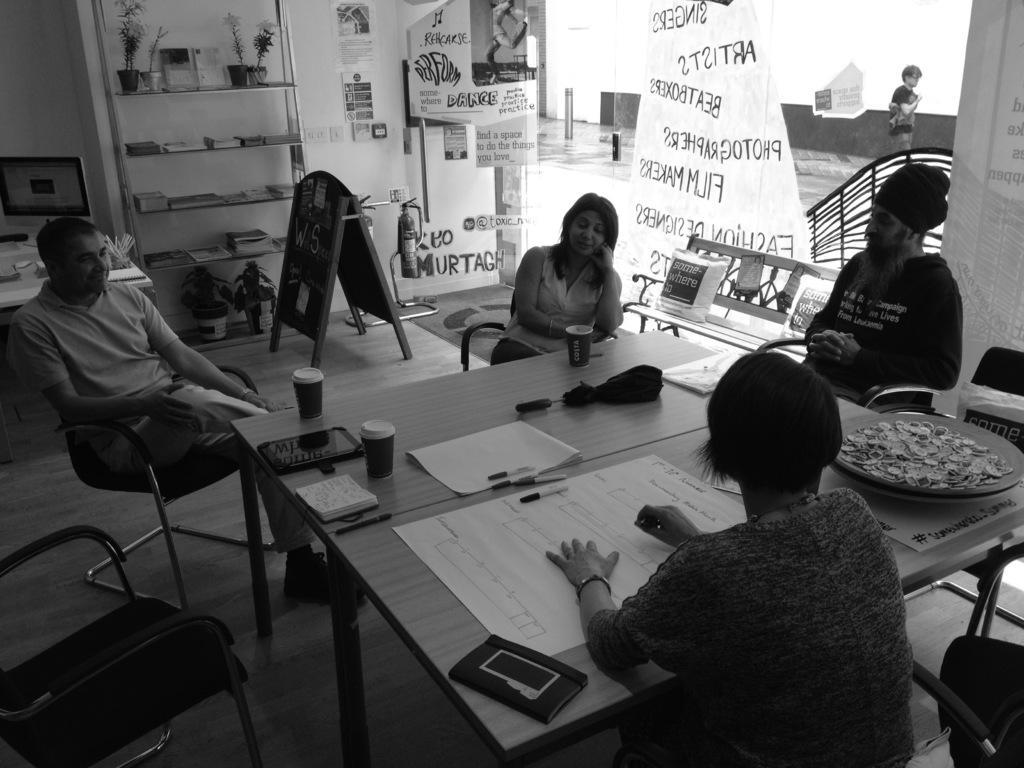Could you give a brief overview of what you see in this image? This picture is clicked inside a room. There are four people sitting on chairs at the table. On the table there is a chart, umbrella, glasses, book, pen and tablet kids. In the background there is wall. There is rack on the wall and things and house plants are placed in it. At the left corner there is monitor on the table. There are charts sticked on the wall. In front of the wall there is a board and hydrogen cylinders. There is also a glass wall and a banner is hanging from outside. Behind the glass wall there is person walking.  